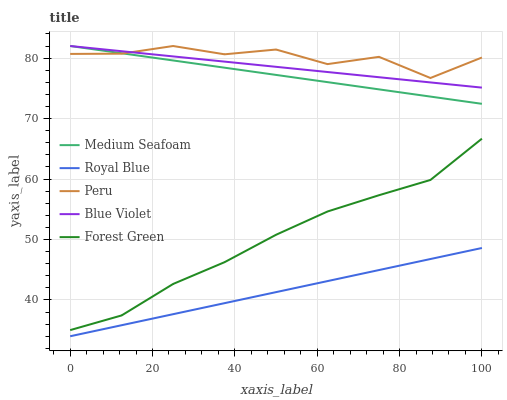Does Royal Blue have the minimum area under the curve?
Answer yes or no. Yes. Does Peru have the maximum area under the curve?
Answer yes or no. Yes. Does Forest Green have the minimum area under the curve?
Answer yes or no. No. Does Forest Green have the maximum area under the curve?
Answer yes or no. No. Is Royal Blue the smoothest?
Answer yes or no. Yes. Is Peru the roughest?
Answer yes or no. Yes. Is Forest Green the smoothest?
Answer yes or no. No. Is Forest Green the roughest?
Answer yes or no. No. Does Royal Blue have the lowest value?
Answer yes or no. Yes. Does Forest Green have the lowest value?
Answer yes or no. No. Does Peru have the highest value?
Answer yes or no. Yes. Does Forest Green have the highest value?
Answer yes or no. No. Is Forest Green less than Blue Violet?
Answer yes or no. Yes. Is Forest Green greater than Royal Blue?
Answer yes or no. Yes. Does Medium Seafoam intersect Blue Violet?
Answer yes or no. Yes. Is Medium Seafoam less than Blue Violet?
Answer yes or no. No. Is Medium Seafoam greater than Blue Violet?
Answer yes or no. No. Does Forest Green intersect Blue Violet?
Answer yes or no. No. 